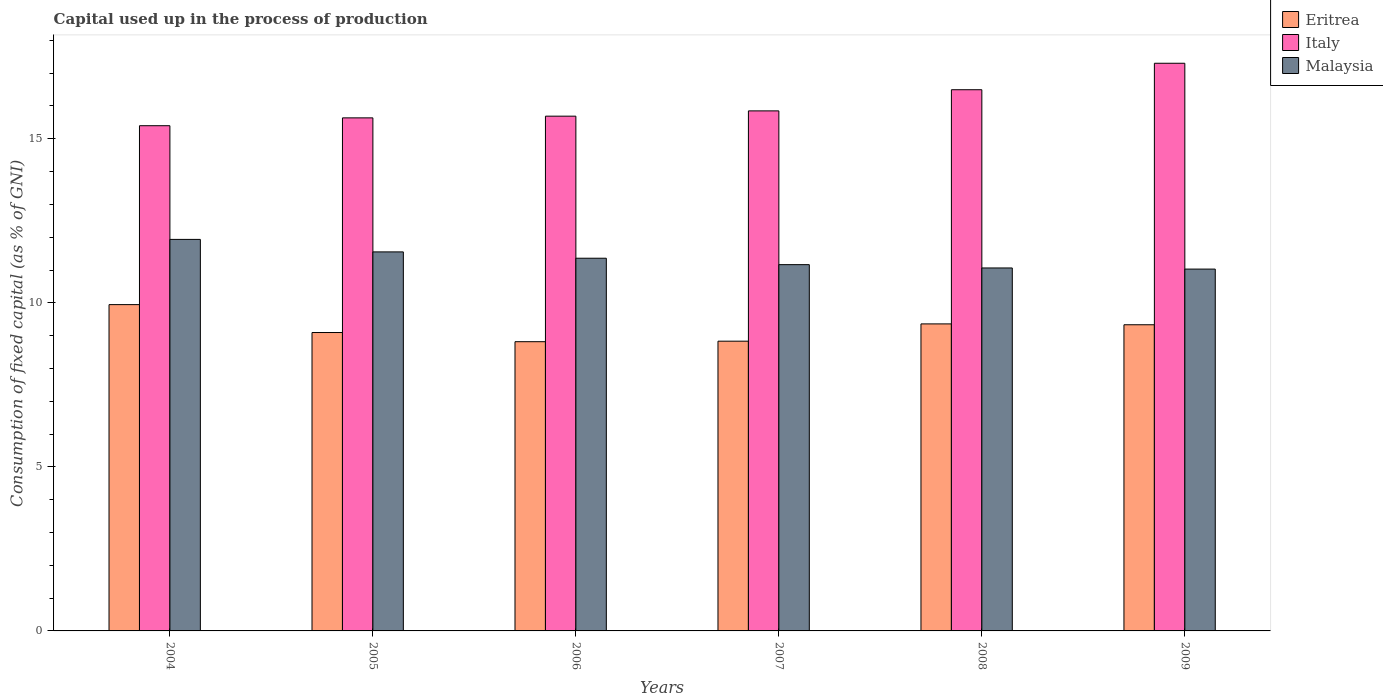How many different coloured bars are there?
Offer a very short reply. 3. Are the number of bars per tick equal to the number of legend labels?
Keep it short and to the point. Yes. How many bars are there on the 1st tick from the left?
Ensure brevity in your answer.  3. How many bars are there on the 5th tick from the right?
Ensure brevity in your answer.  3. What is the label of the 5th group of bars from the left?
Give a very brief answer. 2008. What is the capital used up in the process of production in Italy in 2008?
Give a very brief answer. 16.49. Across all years, what is the maximum capital used up in the process of production in Eritrea?
Provide a succinct answer. 9.95. Across all years, what is the minimum capital used up in the process of production in Malaysia?
Provide a succinct answer. 11.03. In which year was the capital used up in the process of production in Malaysia maximum?
Your answer should be compact. 2004. In which year was the capital used up in the process of production in Malaysia minimum?
Ensure brevity in your answer.  2009. What is the total capital used up in the process of production in Italy in the graph?
Your response must be concise. 96.37. What is the difference between the capital used up in the process of production in Eritrea in 2007 and that in 2009?
Provide a succinct answer. -0.5. What is the difference between the capital used up in the process of production in Italy in 2007 and the capital used up in the process of production in Eritrea in 2006?
Your answer should be compact. 7.03. What is the average capital used up in the process of production in Italy per year?
Provide a short and direct response. 16.06. In the year 2005, what is the difference between the capital used up in the process of production in Italy and capital used up in the process of production in Malaysia?
Give a very brief answer. 4.08. What is the ratio of the capital used up in the process of production in Malaysia in 2006 to that in 2008?
Offer a very short reply. 1.03. Is the capital used up in the process of production in Malaysia in 2005 less than that in 2009?
Provide a succinct answer. No. Is the difference between the capital used up in the process of production in Italy in 2005 and 2007 greater than the difference between the capital used up in the process of production in Malaysia in 2005 and 2007?
Provide a succinct answer. No. What is the difference between the highest and the second highest capital used up in the process of production in Eritrea?
Your answer should be compact. 0.59. What is the difference between the highest and the lowest capital used up in the process of production in Eritrea?
Your answer should be compact. 1.13. What does the 3rd bar from the left in 2005 represents?
Your response must be concise. Malaysia. Is it the case that in every year, the sum of the capital used up in the process of production in Malaysia and capital used up in the process of production in Italy is greater than the capital used up in the process of production in Eritrea?
Offer a terse response. Yes. Are the values on the major ticks of Y-axis written in scientific E-notation?
Offer a terse response. No. Does the graph contain grids?
Your answer should be very brief. No. What is the title of the graph?
Your answer should be very brief. Capital used up in the process of production. What is the label or title of the Y-axis?
Offer a terse response. Consumption of fixed capital (as % of GNI). What is the Consumption of fixed capital (as % of GNI) in Eritrea in 2004?
Offer a terse response. 9.95. What is the Consumption of fixed capital (as % of GNI) in Italy in 2004?
Keep it short and to the point. 15.4. What is the Consumption of fixed capital (as % of GNI) of Malaysia in 2004?
Offer a terse response. 11.93. What is the Consumption of fixed capital (as % of GNI) of Eritrea in 2005?
Offer a terse response. 9.09. What is the Consumption of fixed capital (as % of GNI) of Italy in 2005?
Keep it short and to the point. 15.64. What is the Consumption of fixed capital (as % of GNI) of Malaysia in 2005?
Make the answer very short. 11.55. What is the Consumption of fixed capital (as % of GNI) in Eritrea in 2006?
Provide a succinct answer. 8.82. What is the Consumption of fixed capital (as % of GNI) in Italy in 2006?
Your answer should be compact. 15.69. What is the Consumption of fixed capital (as % of GNI) of Malaysia in 2006?
Ensure brevity in your answer.  11.36. What is the Consumption of fixed capital (as % of GNI) in Eritrea in 2007?
Keep it short and to the point. 8.83. What is the Consumption of fixed capital (as % of GNI) in Italy in 2007?
Your answer should be compact. 15.85. What is the Consumption of fixed capital (as % of GNI) in Malaysia in 2007?
Offer a terse response. 11.16. What is the Consumption of fixed capital (as % of GNI) of Eritrea in 2008?
Provide a short and direct response. 9.36. What is the Consumption of fixed capital (as % of GNI) in Italy in 2008?
Give a very brief answer. 16.49. What is the Consumption of fixed capital (as % of GNI) of Malaysia in 2008?
Provide a succinct answer. 11.06. What is the Consumption of fixed capital (as % of GNI) in Eritrea in 2009?
Offer a very short reply. 9.33. What is the Consumption of fixed capital (as % of GNI) in Italy in 2009?
Provide a short and direct response. 17.3. What is the Consumption of fixed capital (as % of GNI) in Malaysia in 2009?
Offer a very short reply. 11.03. Across all years, what is the maximum Consumption of fixed capital (as % of GNI) of Eritrea?
Make the answer very short. 9.95. Across all years, what is the maximum Consumption of fixed capital (as % of GNI) of Italy?
Provide a short and direct response. 17.3. Across all years, what is the maximum Consumption of fixed capital (as % of GNI) in Malaysia?
Your answer should be very brief. 11.93. Across all years, what is the minimum Consumption of fixed capital (as % of GNI) of Eritrea?
Give a very brief answer. 8.82. Across all years, what is the minimum Consumption of fixed capital (as % of GNI) in Italy?
Your answer should be very brief. 15.4. Across all years, what is the minimum Consumption of fixed capital (as % of GNI) of Malaysia?
Provide a succinct answer. 11.03. What is the total Consumption of fixed capital (as % of GNI) of Eritrea in the graph?
Make the answer very short. 55.37. What is the total Consumption of fixed capital (as % of GNI) of Italy in the graph?
Provide a short and direct response. 96.37. What is the total Consumption of fixed capital (as % of GNI) of Malaysia in the graph?
Offer a very short reply. 68.1. What is the difference between the Consumption of fixed capital (as % of GNI) of Eritrea in 2004 and that in 2005?
Give a very brief answer. 0.85. What is the difference between the Consumption of fixed capital (as % of GNI) of Italy in 2004 and that in 2005?
Your answer should be very brief. -0.24. What is the difference between the Consumption of fixed capital (as % of GNI) in Malaysia in 2004 and that in 2005?
Ensure brevity in your answer.  0.38. What is the difference between the Consumption of fixed capital (as % of GNI) of Eritrea in 2004 and that in 2006?
Offer a very short reply. 1.13. What is the difference between the Consumption of fixed capital (as % of GNI) in Italy in 2004 and that in 2006?
Your answer should be very brief. -0.29. What is the difference between the Consumption of fixed capital (as % of GNI) in Malaysia in 2004 and that in 2006?
Make the answer very short. 0.57. What is the difference between the Consumption of fixed capital (as % of GNI) of Eritrea in 2004 and that in 2007?
Your answer should be compact. 1.11. What is the difference between the Consumption of fixed capital (as % of GNI) of Italy in 2004 and that in 2007?
Offer a very short reply. -0.45. What is the difference between the Consumption of fixed capital (as % of GNI) of Malaysia in 2004 and that in 2007?
Your answer should be compact. 0.77. What is the difference between the Consumption of fixed capital (as % of GNI) of Eritrea in 2004 and that in 2008?
Offer a very short reply. 0.59. What is the difference between the Consumption of fixed capital (as % of GNI) in Italy in 2004 and that in 2008?
Offer a very short reply. -1.1. What is the difference between the Consumption of fixed capital (as % of GNI) of Malaysia in 2004 and that in 2008?
Keep it short and to the point. 0.87. What is the difference between the Consumption of fixed capital (as % of GNI) in Eritrea in 2004 and that in 2009?
Ensure brevity in your answer.  0.61. What is the difference between the Consumption of fixed capital (as % of GNI) of Italy in 2004 and that in 2009?
Your answer should be very brief. -1.9. What is the difference between the Consumption of fixed capital (as % of GNI) of Malaysia in 2004 and that in 2009?
Give a very brief answer. 0.9. What is the difference between the Consumption of fixed capital (as % of GNI) of Eritrea in 2005 and that in 2006?
Keep it short and to the point. 0.28. What is the difference between the Consumption of fixed capital (as % of GNI) of Italy in 2005 and that in 2006?
Provide a short and direct response. -0.05. What is the difference between the Consumption of fixed capital (as % of GNI) in Malaysia in 2005 and that in 2006?
Your answer should be compact. 0.19. What is the difference between the Consumption of fixed capital (as % of GNI) in Eritrea in 2005 and that in 2007?
Offer a very short reply. 0.26. What is the difference between the Consumption of fixed capital (as % of GNI) in Italy in 2005 and that in 2007?
Keep it short and to the point. -0.21. What is the difference between the Consumption of fixed capital (as % of GNI) of Malaysia in 2005 and that in 2007?
Keep it short and to the point. 0.39. What is the difference between the Consumption of fixed capital (as % of GNI) in Eritrea in 2005 and that in 2008?
Provide a succinct answer. -0.26. What is the difference between the Consumption of fixed capital (as % of GNI) in Italy in 2005 and that in 2008?
Give a very brief answer. -0.86. What is the difference between the Consumption of fixed capital (as % of GNI) in Malaysia in 2005 and that in 2008?
Your answer should be very brief. 0.49. What is the difference between the Consumption of fixed capital (as % of GNI) of Eritrea in 2005 and that in 2009?
Make the answer very short. -0.24. What is the difference between the Consumption of fixed capital (as % of GNI) of Italy in 2005 and that in 2009?
Your answer should be compact. -1.66. What is the difference between the Consumption of fixed capital (as % of GNI) in Malaysia in 2005 and that in 2009?
Your answer should be compact. 0.52. What is the difference between the Consumption of fixed capital (as % of GNI) of Eritrea in 2006 and that in 2007?
Offer a terse response. -0.02. What is the difference between the Consumption of fixed capital (as % of GNI) of Italy in 2006 and that in 2007?
Ensure brevity in your answer.  -0.16. What is the difference between the Consumption of fixed capital (as % of GNI) in Malaysia in 2006 and that in 2007?
Provide a short and direct response. 0.2. What is the difference between the Consumption of fixed capital (as % of GNI) of Eritrea in 2006 and that in 2008?
Your answer should be very brief. -0.54. What is the difference between the Consumption of fixed capital (as % of GNI) in Italy in 2006 and that in 2008?
Offer a very short reply. -0.81. What is the difference between the Consumption of fixed capital (as % of GNI) of Malaysia in 2006 and that in 2008?
Keep it short and to the point. 0.3. What is the difference between the Consumption of fixed capital (as % of GNI) in Eritrea in 2006 and that in 2009?
Offer a very short reply. -0.52. What is the difference between the Consumption of fixed capital (as % of GNI) in Italy in 2006 and that in 2009?
Make the answer very short. -1.61. What is the difference between the Consumption of fixed capital (as % of GNI) of Malaysia in 2006 and that in 2009?
Keep it short and to the point. 0.33. What is the difference between the Consumption of fixed capital (as % of GNI) in Eritrea in 2007 and that in 2008?
Give a very brief answer. -0.53. What is the difference between the Consumption of fixed capital (as % of GNI) of Italy in 2007 and that in 2008?
Your response must be concise. -0.64. What is the difference between the Consumption of fixed capital (as % of GNI) of Malaysia in 2007 and that in 2008?
Offer a very short reply. 0.1. What is the difference between the Consumption of fixed capital (as % of GNI) of Eritrea in 2007 and that in 2009?
Give a very brief answer. -0.5. What is the difference between the Consumption of fixed capital (as % of GNI) in Italy in 2007 and that in 2009?
Your response must be concise. -1.45. What is the difference between the Consumption of fixed capital (as % of GNI) of Malaysia in 2007 and that in 2009?
Ensure brevity in your answer.  0.14. What is the difference between the Consumption of fixed capital (as % of GNI) of Eritrea in 2008 and that in 2009?
Your answer should be compact. 0.03. What is the difference between the Consumption of fixed capital (as % of GNI) in Italy in 2008 and that in 2009?
Your response must be concise. -0.81. What is the difference between the Consumption of fixed capital (as % of GNI) of Malaysia in 2008 and that in 2009?
Provide a short and direct response. 0.03. What is the difference between the Consumption of fixed capital (as % of GNI) of Eritrea in 2004 and the Consumption of fixed capital (as % of GNI) of Italy in 2005?
Keep it short and to the point. -5.69. What is the difference between the Consumption of fixed capital (as % of GNI) in Eritrea in 2004 and the Consumption of fixed capital (as % of GNI) in Malaysia in 2005?
Your response must be concise. -1.61. What is the difference between the Consumption of fixed capital (as % of GNI) in Italy in 2004 and the Consumption of fixed capital (as % of GNI) in Malaysia in 2005?
Offer a terse response. 3.85. What is the difference between the Consumption of fixed capital (as % of GNI) of Eritrea in 2004 and the Consumption of fixed capital (as % of GNI) of Italy in 2006?
Provide a short and direct response. -5.74. What is the difference between the Consumption of fixed capital (as % of GNI) in Eritrea in 2004 and the Consumption of fixed capital (as % of GNI) in Malaysia in 2006?
Your response must be concise. -1.41. What is the difference between the Consumption of fixed capital (as % of GNI) of Italy in 2004 and the Consumption of fixed capital (as % of GNI) of Malaysia in 2006?
Make the answer very short. 4.04. What is the difference between the Consumption of fixed capital (as % of GNI) in Eritrea in 2004 and the Consumption of fixed capital (as % of GNI) in Italy in 2007?
Make the answer very short. -5.9. What is the difference between the Consumption of fixed capital (as % of GNI) of Eritrea in 2004 and the Consumption of fixed capital (as % of GNI) of Malaysia in 2007?
Offer a very short reply. -1.22. What is the difference between the Consumption of fixed capital (as % of GNI) in Italy in 2004 and the Consumption of fixed capital (as % of GNI) in Malaysia in 2007?
Make the answer very short. 4.23. What is the difference between the Consumption of fixed capital (as % of GNI) in Eritrea in 2004 and the Consumption of fixed capital (as % of GNI) in Italy in 2008?
Your response must be concise. -6.55. What is the difference between the Consumption of fixed capital (as % of GNI) in Eritrea in 2004 and the Consumption of fixed capital (as % of GNI) in Malaysia in 2008?
Provide a short and direct response. -1.12. What is the difference between the Consumption of fixed capital (as % of GNI) in Italy in 2004 and the Consumption of fixed capital (as % of GNI) in Malaysia in 2008?
Provide a succinct answer. 4.34. What is the difference between the Consumption of fixed capital (as % of GNI) of Eritrea in 2004 and the Consumption of fixed capital (as % of GNI) of Italy in 2009?
Provide a short and direct response. -7.36. What is the difference between the Consumption of fixed capital (as % of GNI) in Eritrea in 2004 and the Consumption of fixed capital (as % of GNI) in Malaysia in 2009?
Make the answer very short. -1.08. What is the difference between the Consumption of fixed capital (as % of GNI) of Italy in 2004 and the Consumption of fixed capital (as % of GNI) of Malaysia in 2009?
Offer a terse response. 4.37. What is the difference between the Consumption of fixed capital (as % of GNI) of Eritrea in 2005 and the Consumption of fixed capital (as % of GNI) of Italy in 2006?
Provide a succinct answer. -6.59. What is the difference between the Consumption of fixed capital (as % of GNI) in Eritrea in 2005 and the Consumption of fixed capital (as % of GNI) in Malaysia in 2006?
Provide a short and direct response. -2.26. What is the difference between the Consumption of fixed capital (as % of GNI) of Italy in 2005 and the Consumption of fixed capital (as % of GNI) of Malaysia in 2006?
Ensure brevity in your answer.  4.28. What is the difference between the Consumption of fixed capital (as % of GNI) of Eritrea in 2005 and the Consumption of fixed capital (as % of GNI) of Italy in 2007?
Your answer should be compact. -6.76. What is the difference between the Consumption of fixed capital (as % of GNI) of Eritrea in 2005 and the Consumption of fixed capital (as % of GNI) of Malaysia in 2007?
Make the answer very short. -2.07. What is the difference between the Consumption of fixed capital (as % of GNI) of Italy in 2005 and the Consumption of fixed capital (as % of GNI) of Malaysia in 2007?
Provide a short and direct response. 4.47. What is the difference between the Consumption of fixed capital (as % of GNI) in Eritrea in 2005 and the Consumption of fixed capital (as % of GNI) in Italy in 2008?
Offer a very short reply. -7.4. What is the difference between the Consumption of fixed capital (as % of GNI) in Eritrea in 2005 and the Consumption of fixed capital (as % of GNI) in Malaysia in 2008?
Provide a succinct answer. -1.97. What is the difference between the Consumption of fixed capital (as % of GNI) of Italy in 2005 and the Consumption of fixed capital (as % of GNI) of Malaysia in 2008?
Make the answer very short. 4.57. What is the difference between the Consumption of fixed capital (as % of GNI) of Eritrea in 2005 and the Consumption of fixed capital (as % of GNI) of Italy in 2009?
Provide a succinct answer. -8.21. What is the difference between the Consumption of fixed capital (as % of GNI) of Eritrea in 2005 and the Consumption of fixed capital (as % of GNI) of Malaysia in 2009?
Your answer should be compact. -1.93. What is the difference between the Consumption of fixed capital (as % of GNI) in Italy in 2005 and the Consumption of fixed capital (as % of GNI) in Malaysia in 2009?
Your answer should be very brief. 4.61. What is the difference between the Consumption of fixed capital (as % of GNI) in Eritrea in 2006 and the Consumption of fixed capital (as % of GNI) in Italy in 2007?
Make the answer very short. -7.03. What is the difference between the Consumption of fixed capital (as % of GNI) of Eritrea in 2006 and the Consumption of fixed capital (as % of GNI) of Malaysia in 2007?
Your response must be concise. -2.35. What is the difference between the Consumption of fixed capital (as % of GNI) of Italy in 2006 and the Consumption of fixed capital (as % of GNI) of Malaysia in 2007?
Provide a succinct answer. 4.53. What is the difference between the Consumption of fixed capital (as % of GNI) in Eritrea in 2006 and the Consumption of fixed capital (as % of GNI) in Italy in 2008?
Offer a very short reply. -7.68. What is the difference between the Consumption of fixed capital (as % of GNI) of Eritrea in 2006 and the Consumption of fixed capital (as % of GNI) of Malaysia in 2008?
Your answer should be very brief. -2.25. What is the difference between the Consumption of fixed capital (as % of GNI) in Italy in 2006 and the Consumption of fixed capital (as % of GNI) in Malaysia in 2008?
Ensure brevity in your answer.  4.63. What is the difference between the Consumption of fixed capital (as % of GNI) of Eritrea in 2006 and the Consumption of fixed capital (as % of GNI) of Italy in 2009?
Your answer should be very brief. -8.49. What is the difference between the Consumption of fixed capital (as % of GNI) of Eritrea in 2006 and the Consumption of fixed capital (as % of GNI) of Malaysia in 2009?
Provide a short and direct response. -2.21. What is the difference between the Consumption of fixed capital (as % of GNI) in Italy in 2006 and the Consumption of fixed capital (as % of GNI) in Malaysia in 2009?
Offer a very short reply. 4.66. What is the difference between the Consumption of fixed capital (as % of GNI) of Eritrea in 2007 and the Consumption of fixed capital (as % of GNI) of Italy in 2008?
Your answer should be compact. -7.66. What is the difference between the Consumption of fixed capital (as % of GNI) in Eritrea in 2007 and the Consumption of fixed capital (as % of GNI) in Malaysia in 2008?
Your response must be concise. -2.23. What is the difference between the Consumption of fixed capital (as % of GNI) in Italy in 2007 and the Consumption of fixed capital (as % of GNI) in Malaysia in 2008?
Keep it short and to the point. 4.79. What is the difference between the Consumption of fixed capital (as % of GNI) in Eritrea in 2007 and the Consumption of fixed capital (as % of GNI) in Italy in 2009?
Keep it short and to the point. -8.47. What is the difference between the Consumption of fixed capital (as % of GNI) of Eritrea in 2007 and the Consumption of fixed capital (as % of GNI) of Malaysia in 2009?
Your answer should be compact. -2.2. What is the difference between the Consumption of fixed capital (as % of GNI) of Italy in 2007 and the Consumption of fixed capital (as % of GNI) of Malaysia in 2009?
Your response must be concise. 4.82. What is the difference between the Consumption of fixed capital (as % of GNI) of Eritrea in 2008 and the Consumption of fixed capital (as % of GNI) of Italy in 2009?
Ensure brevity in your answer.  -7.94. What is the difference between the Consumption of fixed capital (as % of GNI) of Eritrea in 2008 and the Consumption of fixed capital (as % of GNI) of Malaysia in 2009?
Offer a very short reply. -1.67. What is the difference between the Consumption of fixed capital (as % of GNI) in Italy in 2008 and the Consumption of fixed capital (as % of GNI) in Malaysia in 2009?
Make the answer very short. 5.47. What is the average Consumption of fixed capital (as % of GNI) of Eritrea per year?
Give a very brief answer. 9.23. What is the average Consumption of fixed capital (as % of GNI) of Italy per year?
Give a very brief answer. 16.06. What is the average Consumption of fixed capital (as % of GNI) of Malaysia per year?
Offer a terse response. 11.35. In the year 2004, what is the difference between the Consumption of fixed capital (as % of GNI) of Eritrea and Consumption of fixed capital (as % of GNI) of Italy?
Your response must be concise. -5.45. In the year 2004, what is the difference between the Consumption of fixed capital (as % of GNI) of Eritrea and Consumption of fixed capital (as % of GNI) of Malaysia?
Provide a short and direct response. -1.99. In the year 2004, what is the difference between the Consumption of fixed capital (as % of GNI) of Italy and Consumption of fixed capital (as % of GNI) of Malaysia?
Give a very brief answer. 3.47. In the year 2005, what is the difference between the Consumption of fixed capital (as % of GNI) of Eritrea and Consumption of fixed capital (as % of GNI) of Italy?
Provide a short and direct response. -6.54. In the year 2005, what is the difference between the Consumption of fixed capital (as % of GNI) of Eritrea and Consumption of fixed capital (as % of GNI) of Malaysia?
Provide a succinct answer. -2.46. In the year 2005, what is the difference between the Consumption of fixed capital (as % of GNI) in Italy and Consumption of fixed capital (as % of GNI) in Malaysia?
Make the answer very short. 4.08. In the year 2006, what is the difference between the Consumption of fixed capital (as % of GNI) in Eritrea and Consumption of fixed capital (as % of GNI) in Italy?
Offer a very short reply. -6.87. In the year 2006, what is the difference between the Consumption of fixed capital (as % of GNI) of Eritrea and Consumption of fixed capital (as % of GNI) of Malaysia?
Your answer should be very brief. -2.54. In the year 2006, what is the difference between the Consumption of fixed capital (as % of GNI) of Italy and Consumption of fixed capital (as % of GNI) of Malaysia?
Keep it short and to the point. 4.33. In the year 2007, what is the difference between the Consumption of fixed capital (as % of GNI) of Eritrea and Consumption of fixed capital (as % of GNI) of Italy?
Provide a succinct answer. -7.02. In the year 2007, what is the difference between the Consumption of fixed capital (as % of GNI) of Eritrea and Consumption of fixed capital (as % of GNI) of Malaysia?
Offer a terse response. -2.33. In the year 2007, what is the difference between the Consumption of fixed capital (as % of GNI) in Italy and Consumption of fixed capital (as % of GNI) in Malaysia?
Keep it short and to the point. 4.69. In the year 2008, what is the difference between the Consumption of fixed capital (as % of GNI) of Eritrea and Consumption of fixed capital (as % of GNI) of Italy?
Provide a short and direct response. -7.14. In the year 2008, what is the difference between the Consumption of fixed capital (as % of GNI) in Eritrea and Consumption of fixed capital (as % of GNI) in Malaysia?
Provide a succinct answer. -1.7. In the year 2008, what is the difference between the Consumption of fixed capital (as % of GNI) in Italy and Consumption of fixed capital (as % of GNI) in Malaysia?
Make the answer very short. 5.43. In the year 2009, what is the difference between the Consumption of fixed capital (as % of GNI) in Eritrea and Consumption of fixed capital (as % of GNI) in Italy?
Your response must be concise. -7.97. In the year 2009, what is the difference between the Consumption of fixed capital (as % of GNI) in Eritrea and Consumption of fixed capital (as % of GNI) in Malaysia?
Offer a terse response. -1.7. In the year 2009, what is the difference between the Consumption of fixed capital (as % of GNI) of Italy and Consumption of fixed capital (as % of GNI) of Malaysia?
Make the answer very short. 6.27. What is the ratio of the Consumption of fixed capital (as % of GNI) of Eritrea in 2004 to that in 2005?
Make the answer very short. 1.09. What is the ratio of the Consumption of fixed capital (as % of GNI) in Italy in 2004 to that in 2005?
Provide a short and direct response. 0.98. What is the ratio of the Consumption of fixed capital (as % of GNI) in Malaysia in 2004 to that in 2005?
Give a very brief answer. 1.03. What is the ratio of the Consumption of fixed capital (as % of GNI) in Eritrea in 2004 to that in 2006?
Your answer should be very brief. 1.13. What is the ratio of the Consumption of fixed capital (as % of GNI) in Italy in 2004 to that in 2006?
Provide a succinct answer. 0.98. What is the ratio of the Consumption of fixed capital (as % of GNI) of Malaysia in 2004 to that in 2006?
Provide a succinct answer. 1.05. What is the ratio of the Consumption of fixed capital (as % of GNI) of Eritrea in 2004 to that in 2007?
Your answer should be compact. 1.13. What is the ratio of the Consumption of fixed capital (as % of GNI) of Italy in 2004 to that in 2007?
Keep it short and to the point. 0.97. What is the ratio of the Consumption of fixed capital (as % of GNI) in Malaysia in 2004 to that in 2007?
Provide a succinct answer. 1.07. What is the ratio of the Consumption of fixed capital (as % of GNI) in Eritrea in 2004 to that in 2008?
Offer a terse response. 1.06. What is the ratio of the Consumption of fixed capital (as % of GNI) in Italy in 2004 to that in 2008?
Provide a short and direct response. 0.93. What is the ratio of the Consumption of fixed capital (as % of GNI) in Malaysia in 2004 to that in 2008?
Provide a succinct answer. 1.08. What is the ratio of the Consumption of fixed capital (as % of GNI) in Eritrea in 2004 to that in 2009?
Make the answer very short. 1.07. What is the ratio of the Consumption of fixed capital (as % of GNI) of Italy in 2004 to that in 2009?
Offer a terse response. 0.89. What is the ratio of the Consumption of fixed capital (as % of GNI) of Malaysia in 2004 to that in 2009?
Offer a very short reply. 1.08. What is the ratio of the Consumption of fixed capital (as % of GNI) of Eritrea in 2005 to that in 2006?
Your response must be concise. 1.03. What is the ratio of the Consumption of fixed capital (as % of GNI) of Italy in 2005 to that in 2006?
Your response must be concise. 1. What is the ratio of the Consumption of fixed capital (as % of GNI) in Eritrea in 2005 to that in 2007?
Provide a succinct answer. 1.03. What is the ratio of the Consumption of fixed capital (as % of GNI) of Italy in 2005 to that in 2007?
Give a very brief answer. 0.99. What is the ratio of the Consumption of fixed capital (as % of GNI) in Malaysia in 2005 to that in 2007?
Provide a short and direct response. 1.03. What is the ratio of the Consumption of fixed capital (as % of GNI) in Eritrea in 2005 to that in 2008?
Your answer should be compact. 0.97. What is the ratio of the Consumption of fixed capital (as % of GNI) of Italy in 2005 to that in 2008?
Keep it short and to the point. 0.95. What is the ratio of the Consumption of fixed capital (as % of GNI) of Malaysia in 2005 to that in 2008?
Offer a terse response. 1.04. What is the ratio of the Consumption of fixed capital (as % of GNI) of Eritrea in 2005 to that in 2009?
Your answer should be very brief. 0.97. What is the ratio of the Consumption of fixed capital (as % of GNI) in Italy in 2005 to that in 2009?
Your answer should be compact. 0.9. What is the ratio of the Consumption of fixed capital (as % of GNI) of Malaysia in 2005 to that in 2009?
Give a very brief answer. 1.05. What is the ratio of the Consumption of fixed capital (as % of GNI) in Italy in 2006 to that in 2007?
Your answer should be compact. 0.99. What is the ratio of the Consumption of fixed capital (as % of GNI) of Malaysia in 2006 to that in 2007?
Provide a succinct answer. 1.02. What is the ratio of the Consumption of fixed capital (as % of GNI) in Eritrea in 2006 to that in 2008?
Ensure brevity in your answer.  0.94. What is the ratio of the Consumption of fixed capital (as % of GNI) in Italy in 2006 to that in 2008?
Keep it short and to the point. 0.95. What is the ratio of the Consumption of fixed capital (as % of GNI) of Malaysia in 2006 to that in 2008?
Give a very brief answer. 1.03. What is the ratio of the Consumption of fixed capital (as % of GNI) in Eritrea in 2006 to that in 2009?
Provide a succinct answer. 0.94. What is the ratio of the Consumption of fixed capital (as % of GNI) in Italy in 2006 to that in 2009?
Offer a very short reply. 0.91. What is the ratio of the Consumption of fixed capital (as % of GNI) of Eritrea in 2007 to that in 2008?
Your answer should be compact. 0.94. What is the ratio of the Consumption of fixed capital (as % of GNI) in Italy in 2007 to that in 2008?
Ensure brevity in your answer.  0.96. What is the ratio of the Consumption of fixed capital (as % of GNI) of Malaysia in 2007 to that in 2008?
Your response must be concise. 1.01. What is the ratio of the Consumption of fixed capital (as % of GNI) in Eritrea in 2007 to that in 2009?
Provide a succinct answer. 0.95. What is the ratio of the Consumption of fixed capital (as % of GNI) in Italy in 2007 to that in 2009?
Your answer should be compact. 0.92. What is the ratio of the Consumption of fixed capital (as % of GNI) in Malaysia in 2007 to that in 2009?
Provide a short and direct response. 1.01. What is the ratio of the Consumption of fixed capital (as % of GNI) in Eritrea in 2008 to that in 2009?
Offer a terse response. 1. What is the ratio of the Consumption of fixed capital (as % of GNI) in Italy in 2008 to that in 2009?
Provide a short and direct response. 0.95. What is the difference between the highest and the second highest Consumption of fixed capital (as % of GNI) in Eritrea?
Make the answer very short. 0.59. What is the difference between the highest and the second highest Consumption of fixed capital (as % of GNI) in Italy?
Provide a short and direct response. 0.81. What is the difference between the highest and the second highest Consumption of fixed capital (as % of GNI) of Malaysia?
Make the answer very short. 0.38. What is the difference between the highest and the lowest Consumption of fixed capital (as % of GNI) in Eritrea?
Offer a terse response. 1.13. What is the difference between the highest and the lowest Consumption of fixed capital (as % of GNI) in Italy?
Provide a short and direct response. 1.9. What is the difference between the highest and the lowest Consumption of fixed capital (as % of GNI) in Malaysia?
Offer a terse response. 0.9. 